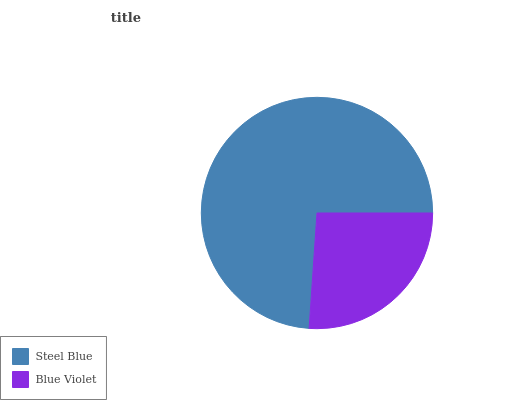Is Blue Violet the minimum?
Answer yes or no. Yes. Is Steel Blue the maximum?
Answer yes or no. Yes. Is Blue Violet the maximum?
Answer yes or no. No. Is Steel Blue greater than Blue Violet?
Answer yes or no. Yes. Is Blue Violet less than Steel Blue?
Answer yes or no. Yes. Is Blue Violet greater than Steel Blue?
Answer yes or no. No. Is Steel Blue less than Blue Violet?
Answer yes or no. No. Is Steel Blue the high median?
Answer yes or no. Yes. Is Blue Violet the low median?
Answer yes or no. Yes. Is Blue Violet the high median?
Answer yes or no. No. Is Steel Blue the low median?
Answer yes or no. No. 